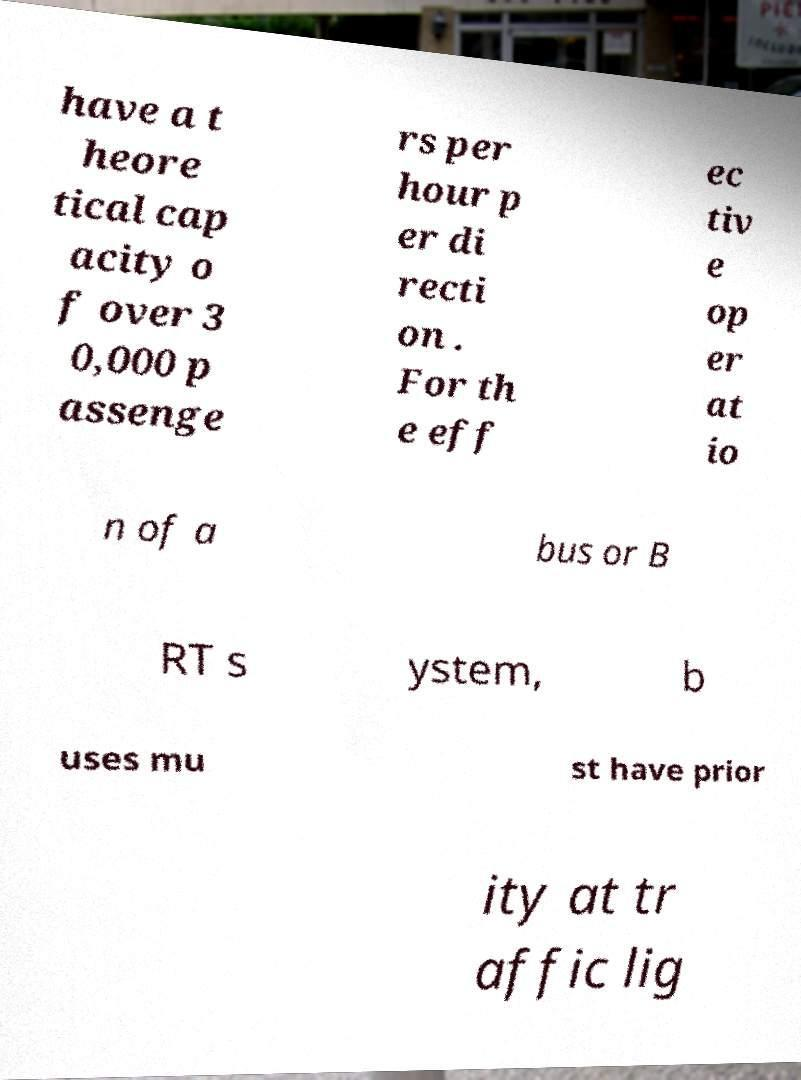Please identify and transcribe the text found in this image. have a t heore tical cap acity o f over 3 0,000 p assenge rs per hour p er di recti on . For th e eff ec tiv e op er at io n of a bus or B RT s ystem, b uses mu st have prior ity at tr affic lig 